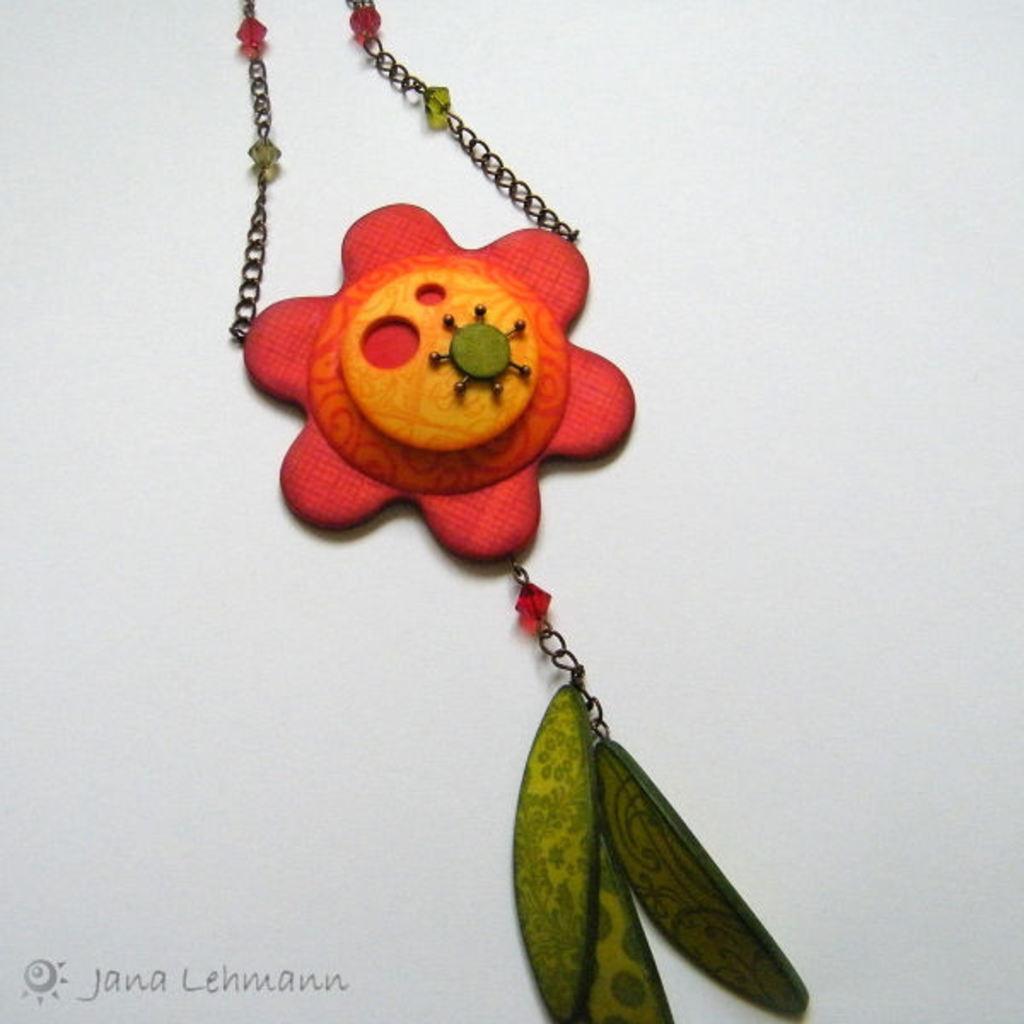Could you give a brief overview of what you see in this image? In the image there is a chain with locket on the floor. 